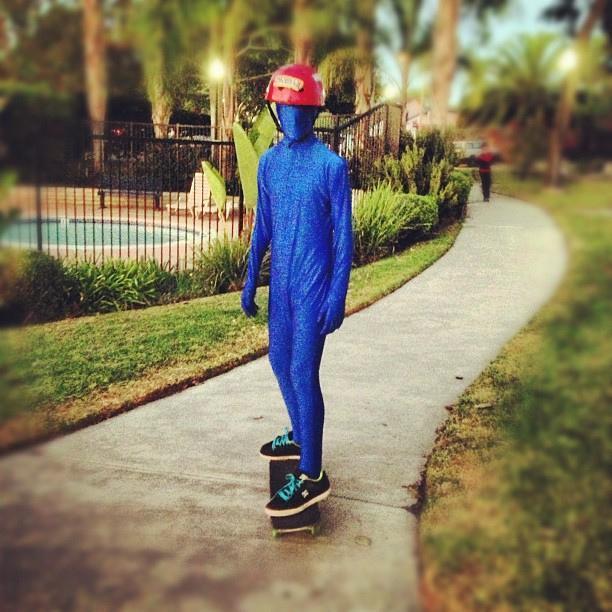What important property does this blue outfit have?
Choose the right answer from the provided options to respond to the question.
Options: Breathable, washable, lightweight, waterproof. Breathable. 